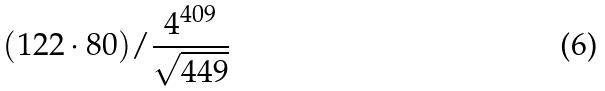<formula> <loc_0><loc_0><loc_500><loc_500>( 1 2 2 \cdot 8 0 ) / \frac { 4 ^ { 4 0 9 } } { \sqrt { 4 4 9 } }</formula> 